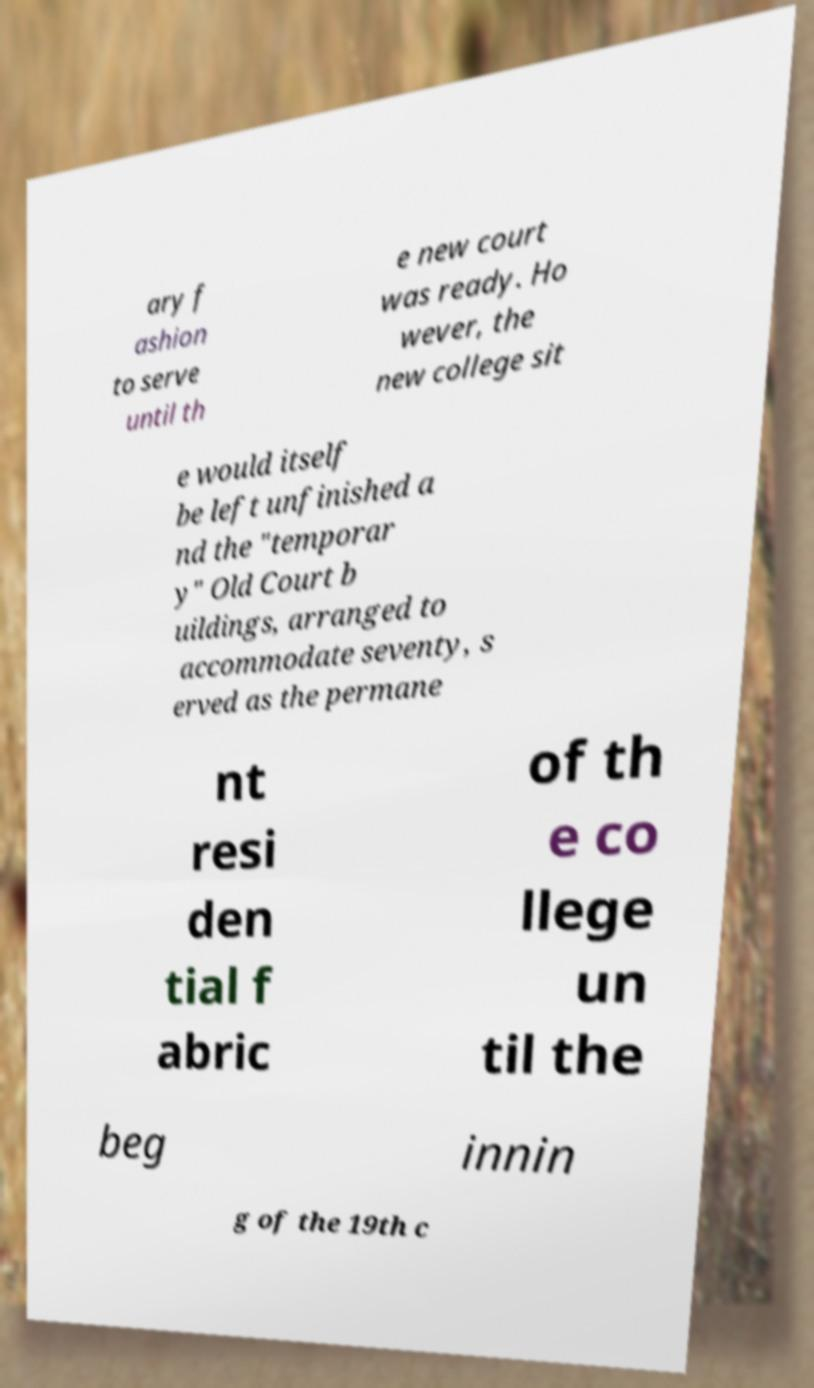Could you extract and type out the text from this image? ary f ashion to serve until th e new court was ready. Ho wever, the new college sit e would itself be left unfinished a nd the "temporar y" Old Court b uildings, arranged to accommodate seventy, s erved as the permane nt resi den tial f abric of th e co llege un til the beg innin g of the 19th c 